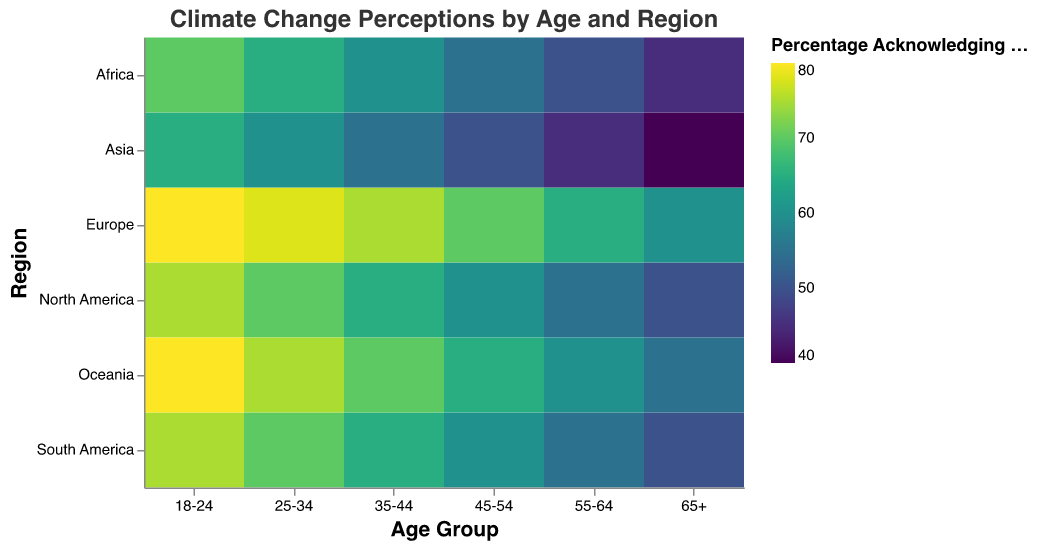What's the highest percentage of the population acknowledging climate change for any region? Looking at the heatmap, the highest percentage recorded is 80%. Both Europe and Oceania in the 18-24 age group show an 80% acknowledgment of climate change.
Answer: 80% Which age group in North America has the lowest percentage acknowledging climate change? In North America, the heatmap shows that the 65+ age group acknowledges climate change the least, with a percentage of 50%.
Answer: 65+ In Asia, how does the percentage of population acknowledging climate change in the 25-34 age group compare to that of the 55-64 age group? In Asia, the percentage of the population in the 25-34 age group acknowledging climate change is 60% whereas for the 55-64 age group, it is 45%. Thus, the 25-34 age group has a higher acknowledgment rate by 15 percentage points.
Answer: 15% What's the average percentage of the population acknowledging climate change for the 35-44 age group across all regions? The percentages for the 35-44 age group across the regions are: North America (65%), Europe (75%), Asia (55%), Africa (60%), South America (65%), Oceania (70%). Summing these percentages gives 65 + 75 + 55 + 60 + 65 + 70 = 390. Dividing by 6 (the number of regions) gives an average of 65%.
Answer: 65% How does the acknowledgment of climate change in Africa for the 45-54 age group compare to that of Europe for the same age group? In Africa, the percentage is 55%, while in Europe it is 70%. Therefore, Europe has a higher acknowledgment rate by 15 percentage points compared to Africa for the 45-54 age group.
Answer: 15% Which region has the most uniform acknowledgment of climate change across all age groups? Examining the heatmap, Europe shows relatively uniform acknowledgment percentages across age groups, ranging from 60% to 80%. The difference between the highest and lowest percentages is only 20 percentage points.
Answer: Europe What's the difference in the percentage of population acknowledging climate change between the youngest (18-24) and the oldest (65+) age groups in South America? In South America, the percentage for the 18-24 age group is 75% and for the 65+ age group is 50%. The difference between these two percentages is 75 - 50 = 25 percentage points.
Answer: 25 In which region does the 25-34 age group acknowledge climate change the least? The heatmap shows that in Asia, the 25-34 age group acknowledges climate change at 60%, which is the lowest percentage for this age group across all regions.
Answer: Asia How does the trend in climate change acknowledgment vary with age in Oceania? In Oceania, the acknowledgement percentages decrease with increasing age: 80% (18-24), 75% (25-34), 70% (35-44), 65% (45-54), 60% (55-64), 55% (65+). This shows a clear decreasing trend as the age increases.
Answer: Decreases with age What age group and region combination has the highest percentage of climate change denial? While the heatmap specifically highlights acknowledgment rates, data points from the climate change denial percentages indicate that the 65+ age group in Asia, with a 50% denial rate, has the highest percentage of climate change denial.
Answer: 65+ in Asia 